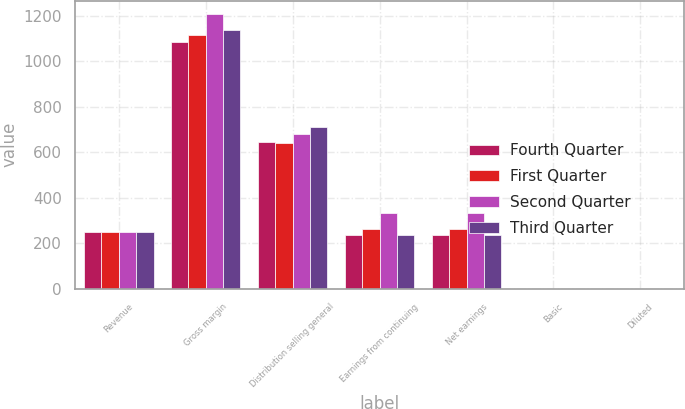Convert chart to OTSL. <chart><loc_0><loc_0><loc_500><loc_500><stacked_bar_chart><ecel><fcel>Revenue<fcel>Gross margin<fcel>Distribution selling general<fcel>Earnings from continuing<fcel>Net earnings<fcel>Basic<fcel>Diluted<nl><fcel>Fourth Quarter<fcel>249.5<fcel>1084<fcel>644<fcel>237<fcel>237<fcel>0.69<fcel>0.68<nl><fcel>First Quarter<fcel>249.5<fcel>1114<fcel>640<fcel>264<fcel>262<fcel>0.77<fcel>0.76<nl><fcel>Second Quarter<fcel>249.5<fcel>1207<fcel>683<fcel>332<fcel>333<fcel>0.96<fcel>0.95<nl><fcel>Third Quarter<fcel>249.5<fcel>1136<fcel>712<fcel>236<fcel>236<fcel>0.68<fcel>0.68<nl></chart> 